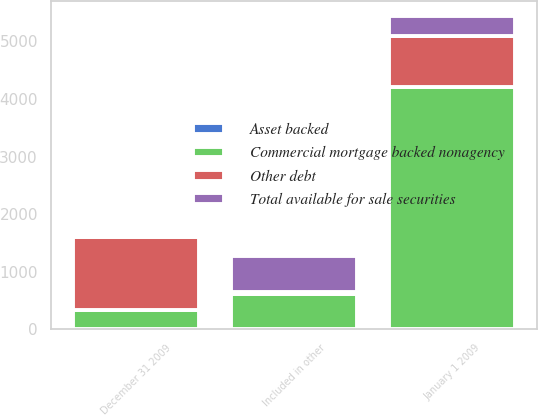Convert chart. <chart><loc_0><loc_0><loc_500><loc_500><stacked_bar_chart><ecel><fcel>January 1 2009<fcel>Included in other<fcel>December 31 2009<nl><fcel>Asset backed<fcel>7<fcel>2<fcel>5<nl><fcel>Commercial mortgage backed nonagency<fcel>4203<fcel>616<fcel>337<nl><fcel>Total available for sale securities<fcel>337<fcel>627<fcel>6<nl><fcel>Other debt<fcel>892<fcel>22<fcel>1254<nl></chart> 